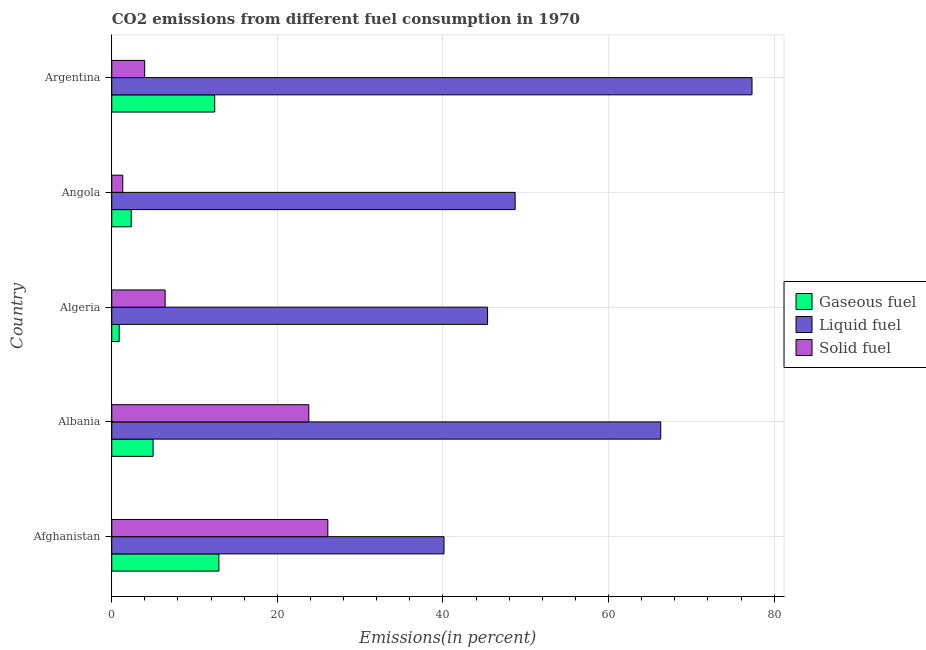How many different coloured bars are there?
Your answer should be compact. 3. Are the number of bars per tick equal to the number of legend labels?
Offer a terse response. Yes. How many bars are there on the 5th tick from the top?
Offer a terse response. 3. What is the label of the 3rd group of bars from the top?
Your answer should be compact. Algeria. What is the percentage of liquid fuel emission in Afghanistan?
Provide a succinct answer. 40.13. Across all countries, what is the maximum percentage of gaseous fuel emission?
Make the answer very short. 12.94. Across all countries, what is the minimum percentage of gaseous fuel emission?
Provide a succinct answer. 0.9. In which country was the percentage of liquid fuel emission maximum?
Ensure brevity in your answer.  Argentina. In which country was the percentage of liquid fuel emission minimum?
Ensure brevity in your answer.  Afghanistan. What is the total percentage of solid fuel emission in the graph?
Your response must be concise. 61.65. What is the difference between the percentage of liquid fuel emission in Algeria and that in Angola?
Keep it short and to the point. -3.33. What is the difference between the percentage of solid fuel emission in Argentina and the percentage of gaseous fuel emission in Afghanistan?
Your answer should be compact. -8.96. What is the average percentage of solid fuel emission per country?
Your response must be concise. 12.33. What is the difference between the percentage of gaseous fuel emission and percentage of liquid fuel emission in Argentina?
Provide a succinct answer. -64.89. What is the ratio of the percentage of solid fuel emission in Afghanistan to that in Albania?
Your answer should be compact. 1.1. Is the percentage of liquid fuel emission in Albania less than that in Algeria?
Your answer should be compact. No. What is the difference between the highest and the second highest percentage of liquid fuel emission?
Your response must be concise. 11.02. What is the difference between the highest and the lowest percentage of liquid fuel emission?
Provide a succinct answer. 37.2. In how many countries, is the percentage of gaseous fuel emission greater than the average percentage of gaseous fuel emission taken over all countries?
Your answer should be compact. 2. What does the 1st bar from the top in Afghanistan represents?
Keep it short and to the point. Solid fuel. What does the 1st bar from the bottom in Algeria represents?
Give a very brief answer. Gaseous fuel. Does the graph contain any zero values?
Your response must be concise. No. Does the graph contain grids?
Your response must be concise. Yes. How are the legend labels stacked?
Offer a very short reply. Vertical. What is the title of the graph?
Your response must be concise. CO2 emissions from different fuel consumption in 1970. Does "Wage workers" appear as one of the legend labels in the graph?
Ensure brevity in your answer.  No. What is the label or title of the X-axis?
Provide a short and direct response. Emissions(in percent). What is the label or title of the Y-axis?
Offer a very short reply. Country. What is the Emissions(in percent) of Gaseous fuel in Afghanistan?
Keep it short and to the point. 12.94. What is the Emissions(in percent) of Liquid fuel in Afghanistan?
Your answer should be compact. 40.13. What is the Emissions(in percent) in Solid fuel in Afghanistan?
Your answer should be compact. 26.1. What is the Emissions(in percent) of Gaseous fuel in Albania?
Ensure brevity in your answer.  5. What is the Emissions(in percent) of Liquid fuel in Albania?
Your response must be concise. 66.31. What is the Emissions(in percent) of Solid fuel in Albania?
Give a very brief answer. 23.8. What is the Emissions(in percent) in Gaseous fuel in Algeria?
Your answer should be very brief. 0.9. What is the Emissions(in percent) in Liquid fuel in Algeria?
Offer a very short reply. 45.39. What is the Emissions(in percent) of Solid fuel in Algeria?
Keep it short and to the point. 6.45. What is the Emissions(in percent) of Gaseous fuel in Angola?
Offer a very short reply. 2.35. What is the Emissions(in percent) of Liquid fuel in Angola?
Your answer should be compact. 48.72. What is the Emissions(in percent) in Solid fuel in Angola?
Offer a very short reply. 1.33. What is the Emissions(in percent) of Gaseous fuel in Argentina?
Keep it short and to the point. 12.44. What is the Emissions(in percent) of Liquid fuel in Argentina?
Offer a terse response. 77.33. What is the Emissions(in percent) of Solid fuel in Argentina?
Your answer should be very brief. 3.98. Across all countries, what is the maximum Emissions(in percent) in Gaseous fuel?
Offer a terse response. 12.94. Across all countries, what is the maximum Emissions(in percent) in Liquid fuel?
Provide a short and direct response. 77.33. Across all countries, what is the maximum Emissions(in percent) of Solid fuel?
Provide a short and direct response. 26.1. Across all countries, what is the minimum Emissions(in percent) of Gaseous fuel?
Make the answer very short. 0.9. Across all countries, what is the minimum Emissions(in percent) of Liquid fuel?
Provide a short and direct response. 40.13. Across all countries, what is the minimum Emissions(in percent) in Solid fuel?
Ensure brevity in your answer.  1.33. What is the total Emissions(in percent) of Gaseous fuel in the graph?
Your response must be concise. 33.62. What is the total Emissions(in percent) of Liquid fuel in the graph?
Your response must be concise. 277.88. What is the total Emissions(in percent) of Solid fuel in the graph?
Your answer should be very brief. 61.65. What is the difference between the Emissions(in percent) in Gaseous fuel in Afghanistan and that in Albania?
Give a very brief answer. 7.94. What is the difference between the Emissions(in percent) in Liquid fuel in Afghanistan and that in Albania?
Offer a terse response. -26.18. What is the difference between the Emissions(in percent) of Solid fuel in Afghanistan and that in Albania?
Keep it short and to the point. 2.3. What is the difference between the Emissions(in percent) of Gaseous fuel in Afghanistan and that in Algeria?
Provide a short and direct response. 12.04. What is the difference between the Emissions(in percent) of Liquid fuel in Afghanistan and that in Algeria?
Provide a short and direct response. -5.26. What is the difference between the Emissions(in percent) of Solid fuel in Afghanistan and that in Algeria?
Provide a succinct answer. 19.65. What is the difference between the Emissions(in percent) in Gaseous fuel in Afghanistan and that in Angola?
Provide a short and direct response. 10.58. What is the difference between the Emissions(in percent) in Liquid fuel in Afghanistan and that in Angola?
Your answer should be very brief. -8.59. What is the difference between the Emissions(in percent) in Solid fuel in Afghanistan and that in Angola?
Provide a succinct answer. 24.77. What is the difference between the Emissions(in percent) of Gaseous fuel in Afghanistan and that in Argentina?
Your answer should be compact. 0.5. What is the difference between the Emissions(in percent) in Liquid fuel in Afghanistan and that in Argentina?
Offer a terse response. -37.2. What is the difference between the Emissions(in percent) of Solid fuel in Afghanistan and that in Argentina?
Your response must be concise. 22.12. What is the difference between the Emissions(in percent) in Gaseous fuel in Albania and that in Algeria?
Your answer should be compact. 4.1. What is the difference between the Emissions(in percent) in Liquid fuel in Albania and that in Algeria?
Give a very brief answer. 20.92. What is the difference between the Emissions(in percent) of Solid fuel in Albania and that in Algeria?
Your response must be concise. 17.35. What is the difference between the Emissions(in percent) in Gaseous fuel in Albania and that in Angola?
Give a very brief answer. 2.64. What is the difference between the Emissions(in percent) in Liquid fuel in Albania and that in Angola?
Keep it short and to the point. 17.59. What is the difference between the Emissions(in percent) in Solid fuel in Albania and that in Angola?
Ensure brevity in your answer.  22.47. What is the difference between the Emissions(in percent) of Gaseous fuel in Albania and that in Argentina?
Your response must be concise. -7.44. What is the difference between the Emissions(in percent) in Liquid fuel in Albania and that in Argentina?
Your answer should be very brief. -11.02. What is the difference between the Emissions(in percent) of Solid fuel in Albania and that in Argentina?
Your answer should be very brief. 19.82. What is the difference between the Emissions(in percent) of Gaseous fuel in Algeria and that in Angola?
Keep it short and to the point. -1.45. What is the difference between the Emissions(in percent) of Liquid fuel in Algeria and that in Angola?
Ensure brevity in your answer.  -3.33. What is the difference between the Emissions(in percent) of Solid fuel in Algeria and that in Angola?
Give a very brief answer. 5.12. What is the difference between the Emissions(in percent) in Gaseous fuel in Algeria and that in Argentina?
Your answer should be compact. -11.54. What is the difference between the Emissions(in percent) in Liquid fuel in Algeria and that in Argentina?
Give a very brief answer. -31.94. What is the difference between the Emissions(in percent) in Solid fuel in Algeria and that in Argentina?
Your answer should be compact. 2.47. What is the difference between the Emissions(in percent) in Gaseous fuel in Angola and that in Argentina?
Make the answer very short. -10.08. What is the difference between the Emissions(in percent) in Liquid fuel in Angola and that in Argentina?
Offer a very short reply. -28.61. What is the difference between the Emissions(in percent) of Solid fuel in Angola and that in Argentina?
Give a very brief answer. -2.65. What is the difference between the Emissions(in percent) of Gaseous fuel in Afghanistan and the Emissions(in percent) of Liquid fuel in Albania?
Keep it short and to the point. -53.37. What is the difference between the Emissions(in percent) in Gaseous fuel in Afghanistan and the Emissions(in percent) in Solid fuel in Albania?
Your answer should be very brief. -10.86. What is the difference between the Emissions(in percent) in Liquid fuel in Afghanistan and the Emissions(in percent) in Solid fuel in Albania?
Keep it short and to the point. 16.33. What is the difference between the Emissions(in percent) of Gaseous fuel in Afghanistan and the Emissions(in percent) of Liquid fuel in Algeria?
Your answer should be compact. -32.45. What is the difference between the Emissions(in percent) of Gaseous fuel in Afghanistan and the Emissions(in percent) of Solid fuel in Algeria?
Provide a succinct answer. 6.49. What is the difference between the Emissions(in percent) in Liquid fuel in Afghanistan and the Emissions(in percent) in Solid fuel in Algeria?
Keep it short and to the point. 33.69. What is the difference between the Emissions(in percent) in Gaseous fuel in Afghanistan and the Emissions(in percent) in Liquid fuel in Angola?
Keep it short and to the point. -35.78. What is the difference between the Emissions(in percent) in Gaseous fuel in Afghanistan and the Emissions(in percent) in Solid fuel in Angola?
Your answer should be compact. 11.61. What is the difference between the Emissions(in percent) in Liquid fuel in Afghanistan and the Emissions(in percent) in Solid fuel in Angola?
Provide a short and direct response. 38.8. What is the difference between the Emissions(in percent) of Gaseous fuel in Afghanistan and the Emissions(in percent) of Liquid fuel in Argentina?
Your answer should be compact. -64.39. What is the difference between the Emissions(in percent) in Gaseous fuel in Afghanistan and the Emissions(in percent) in Solid fuel in Argentina?
Offer a very short reply. 8.96. What is the difference between the Emissions(in percent) in Liquid fuel in Afghanistan and the Emissions(in percent) in Solid fuel in Argentina?
Make the answer very short. 36.16. What is the difference between the Emissions(in percent) of Gaseous fuel in Albania and the Emissions(in percent) of Liquid fuel in Algeria?
Keep it short and to the point. -40.4. What is the difference between the Emissions(in percent) of Gaseous fuel in Albania and the Emissions(in percent) of Solid fuel in Algeria?
Your answer should be compact. -1.45. What is the difference between the Emissions(in percent) in Liquid fuel in Albania and the Emissions(in percent) in Solid fuel in Algeria?
Provide a short and direct response. 59.86. What is the difference between the Emissions(in percent) of Gaseous fuel in Albania and the Emissions(in percent) of Liquid fuel in Angola?
Keep it short and to the point. -43.73. What is the difference between the Emissions(in percent) of Gaseous fuel in Albania and the Emissions(in percent) of Solid fuel in Angola?
Provide a short and direct response. 3.66. What is the difference between the Emissions(in percent) in Liquid fuel in Albania and the Emissions(in percent) in Solid fuel in Angola?
Keep it short and to the point. 64.98. What is the difference between the Emissions(in percent) of Gaseous fuel in Albania and the Emissions(in percent) of Liquid fuel in Argentina?
Your response must be concise. -72.33. What is the difference between the Emissions(in percent) in Gaseous fuel in Albania and the Emissions(in percent) in Solid fuel in Argentina?
Give a very brief answer. 1.02. What is the difference between the Emissions(in percent) of Liquid fuel in Albania and the Emissions(in percent) of Solid fuel in Argentina?
Provide a short and direct response. 62.33. What is the difference between the Emissions(in percent) in Gaseous fuel in Algeria and the Emissions(in percent) in Liquid fuel in Angola?
Keep it short and to the point. -47.82. What is the difference between the Emissions(in percent) of Gaseous fuel in Algeria and the Emissions(in percent) of Solid fuel in Angola?
Keep it short and to the point. -0.43. What is the difference between the Emissions(in percent) of Liquid fuel in Algeria and the Emissions(in percent) of Solid fuel in Angola?
Provide a succinct answer. 44.06. What is the difference between the Emissions(in percent) in Gaseous fuel in Algeria and the Emissions(in percent) in Liquid fuel in Argentina?
Ensure brevity in your answer.  -76.43. What is the difference between the Emissions(in percent) in Gaseous fuel in Algeria and the Emissions(in percent) in Solid fuel in Argentina?
Your answer should be very brief. -3.08. What is the difference between the Emissions(in percent) in Liquid fuel in Algeria and the Emissions(in percent) in Solid fuel in Argentina?
Give a very brief answer. 41.41. What is the difference between the Emissions(in percent) in Gaseous fuel in Angola and the Emissions(in percent) in Liquid fuel in Argentina?
Provide a succinct answer. -74.97. What is the difference between the Emissions(in percent) of Gaseous fuel in Angola and the Emissions(in percent) of Solid fuel in Argentina?
Offer a terse response. -1.62. What is the difference between the Emissions(in percent) of Liquid fuel in Angola and the Emissions(in percent) of Solid fuel in Argentina?
Ensure brevity in your answer.  44.74. What is the average Emissions(in percent) of Gaseous fuel per country?
Offer a very short reply. 6.72. What is the average Emissions(in percent) of Liquid fuel per country?
Your response must be concise. 55.58. What is the average Emissions(in percent) of Solid fuel per country?
Your answer should be compact. 12.33. What is the difference between the Emissions(in percent) in Gaseous fuel and Emissions(in percent) in Liquid fuel in Afghanistan?
Provide a short and direct response. -27.19. What is the difference between the Emissions(in percent) of Gaseous fuel and Emissions(in percent) of Solid fuel in Afghanistan?
Your answer should be compact. -13.16. What is the difference between the Emissions(in percent) of Liquid fuel and Emissions(in percent) of Solid fuel in Afghanistan?
Your answer should be compact. 14.04. What is the difference between the Emissions(in percent) of Gaseous fuel and Emissions(in percent) of Liquid fuel in Albania?
Offer a very short reply. -61.31. What is the difference between the Emissions(in percent) in Gaseous fuel and Emissions(in percent) in Solid fuel in Albania?
Offer a terse response. -18.81. What is the difference between the Emissions(in percent) in Liquid fuel and Emissions(in percent) in Solid fuel in Albania?
Your response must be concise. 42.51. What is the difference between the Emissions(in percent) of Gaseous fuel and Emissions(in percent) of Liquid fuel in Algeria?
Keep it short and to the point. -44.49. What is the difference between the Emissions(in percent) of Gaseous fuel and Emissions(in percent) of Solid fuel in Algeria?
Offer a terse response. -5.55. What is the difference between the Emissions(in percent) in Liquid fuel and Emissions(in percent) in Solid fuel in Algeria?
Offer a terse response. 38.94. What is the difference between the Emissions(in percent) of Gaseous fuel and Emissions(in percent) of Liquid fuel in Angola?
Offer a very short reply. -46.37. What is the difference between the Emissions(in percent) in Gaseous fuel and Emissions(in percent) in Solid fuel in Angola?
Your response must be concise. 1.02. What is the difference between the Emissions(in percent) of Liquid fuel and Emissions(in percent) of Solid fuel in Angola?
Your response must be concise. 47.39. What is the difference between the Emissions(in percent) in Gaseous fuel and Emissions(in percent) in Liquid fuel in Argentina?
Your answer should be very brief. -64.89. What is the difference between the Emissions(in percent) in Gaseous fuel and Emissions(in percent) in Solid fuel in Argentina?
Provide a short and direct response. 8.46. What is the difference between the Emissions(in percent) in Liquid fuel and Emissions(in percent) in Solid fuel in Argentina?
Make the answer very short. 73.35. What is the ratio of the Emissions(in percent) in Gaseous fuel in Afghanistan to that in Albania?
Offer a very short reply. 2.59. What is the ratio of the Emissions(in percent) of Liquid fuel in Afghanistan to that in Albania?
Offer a very short reply. 0.61. What is the ratio of the Emissions(in percent) in Solid fuel in Afghanistan to that in Albania?
Offer a terse response. 1.1. What is the ratio of the Emissions(in percent) of Gaseous fuel in Afghanistan to that in Algeria?
Offer a terse response. 14.38. What is the ratio of the Emissions(in percent) in Liquid fuel in Afghanistan to that in Algeria?
Ensure brevity in your answer.  0.88. What is the ratio of the Emissions(in percent) of Solid fuel in Afghanistan to that in Algeria?
Ensure brevity in your answer.  4.05. What is the ratio of the Emissions(in percent) in Gaseous fuel in Afghanistan to that in Angola?
Offer a very short reply. 5.5. What is the ratio of the Emissions(in percent) of Liquid fuel in Afghanistan to that in Angola?
Provide a succinct answer. 0.82. What is the ratio of the Emissions(in percent) in Solid fuel in Afghanistan to that in Angola?
Your answer should be very brief. 19.61. What is the ratio of the Emissions(in percent) of Gaseous fuel in Afghanistan to that in Argentina?
Offer a terse response. 1.04. What is the ratio of the Emissions(in percent) in Liquid fuel in Afghanistan to that in Argentina?
Your response must be concise. 0.52. What is the ratio of the Emissions(in percent) of Solid fuel in Afghanistan to that in Argentina?
Offer a terse response. 6.56. What is the ratio of the Emissions(in percent) of Gaseous fuel in Albania to that in Algeria?
Your answer should be compact. 5.55. What is the ratio of the Emissions(in percent) in Liquid fuel in Albania to that in Algeria?
Provide a short and direct response. 1.46. What is the ratio of the Emissions(in percent) in Solid fuel in Albania to that in Algeria?
Your answer should be very brief. 3.69. What is the ratio of the Emissions(in percent) of Gaseous fuel in Albania to that in Angola?
Ensure brevity in your answer.  2.12. What is the ratio of the Emissions(in percent) of Liquid fuel in Albania to that in Angola?
Offer a terse response. 1.36. What is the ratio of the Emissions(in percent) in Solid fuel in Albania to that in Angola?
Your answer should be compact. 17.89. What is the ratio of the Emissions(in percent) of Gaseous fuel in Albania to that in Argentina?
Your response must be concise. 0.4. What is the ratio of the Emissions(in percent) in Liquid fuel in Albania to that in Argentina?
Give a very brief answer. 0.86. What is the ratio of the Emissions(in percent) of Solid fuel in Albania to that in Argentina?
Give a very brief answer. 5.99. What is the ratio of the Emissions(in percent) in Gaseous fuel in Algeria to that in Angola?
Give a very brief answer. 0.38. What is the ratio of the Emissions(in percent) of Liquid fuel in Algeria to that in Angola?
Your answer should be very brief. 0.93. What is the ratio of the Emissions(in percent) of Solid fuel in Algeria to that in Angola?
Your answer should be compact. 4.84. What is the ratio of the Emissions(in percent) of Gaseous fuel in Algeria to that in Argentina?
Give a very brief answer. 0.07. What is the ratio of the Emissions(in percent) in Liquid fuel in Algeria to that in Argentina?
Provide a succinct answer. 0.59. What is the ratio of the Emissions(in percent) of Solid fuel in Algeria to that in Argentina?
Your response must be concise. 1.62. What is the ratio of the Emissions(in percent) in Gaseous fuel in Angola to that in Argentina?
Your answer should be compact. 0.19. What is the ratio of the Emissions(in percent) in Liquid fuel in Angola to that in Argentina?
Give a very brief answer. 0.63. What is the ratio of the Emissions(in percent) in Solid fuel in Angola to that in Argentina?
Your answer should be very brief. 0.33. What is the difference between the highest and the second highest Emissions(in percent) in Gaseous fuel?
Make the answer very short. 0.5. What is the difference between the highest and the second highest Emissions(in percent) in Liquid fuel?
Provide a succinct answer. 11.02. What is the difference between the highest and the second highest Emissions(in percent) of Solid fuel?
Your answer should be very brief. 2.3. What is the difference between the highest and the lowest Emissions(in percent) of Gaseous fuel?
Keep it short and to the point. 12.04. What is the difference between the highest and the lowest Emissions(in percent) of Liquid fuel?
Your answer should be very brief. 37.2. What is the difference between the highest and the lowest Emissions(in percent) of Solid fuel?
Your answer should be very brief. 24.77. 